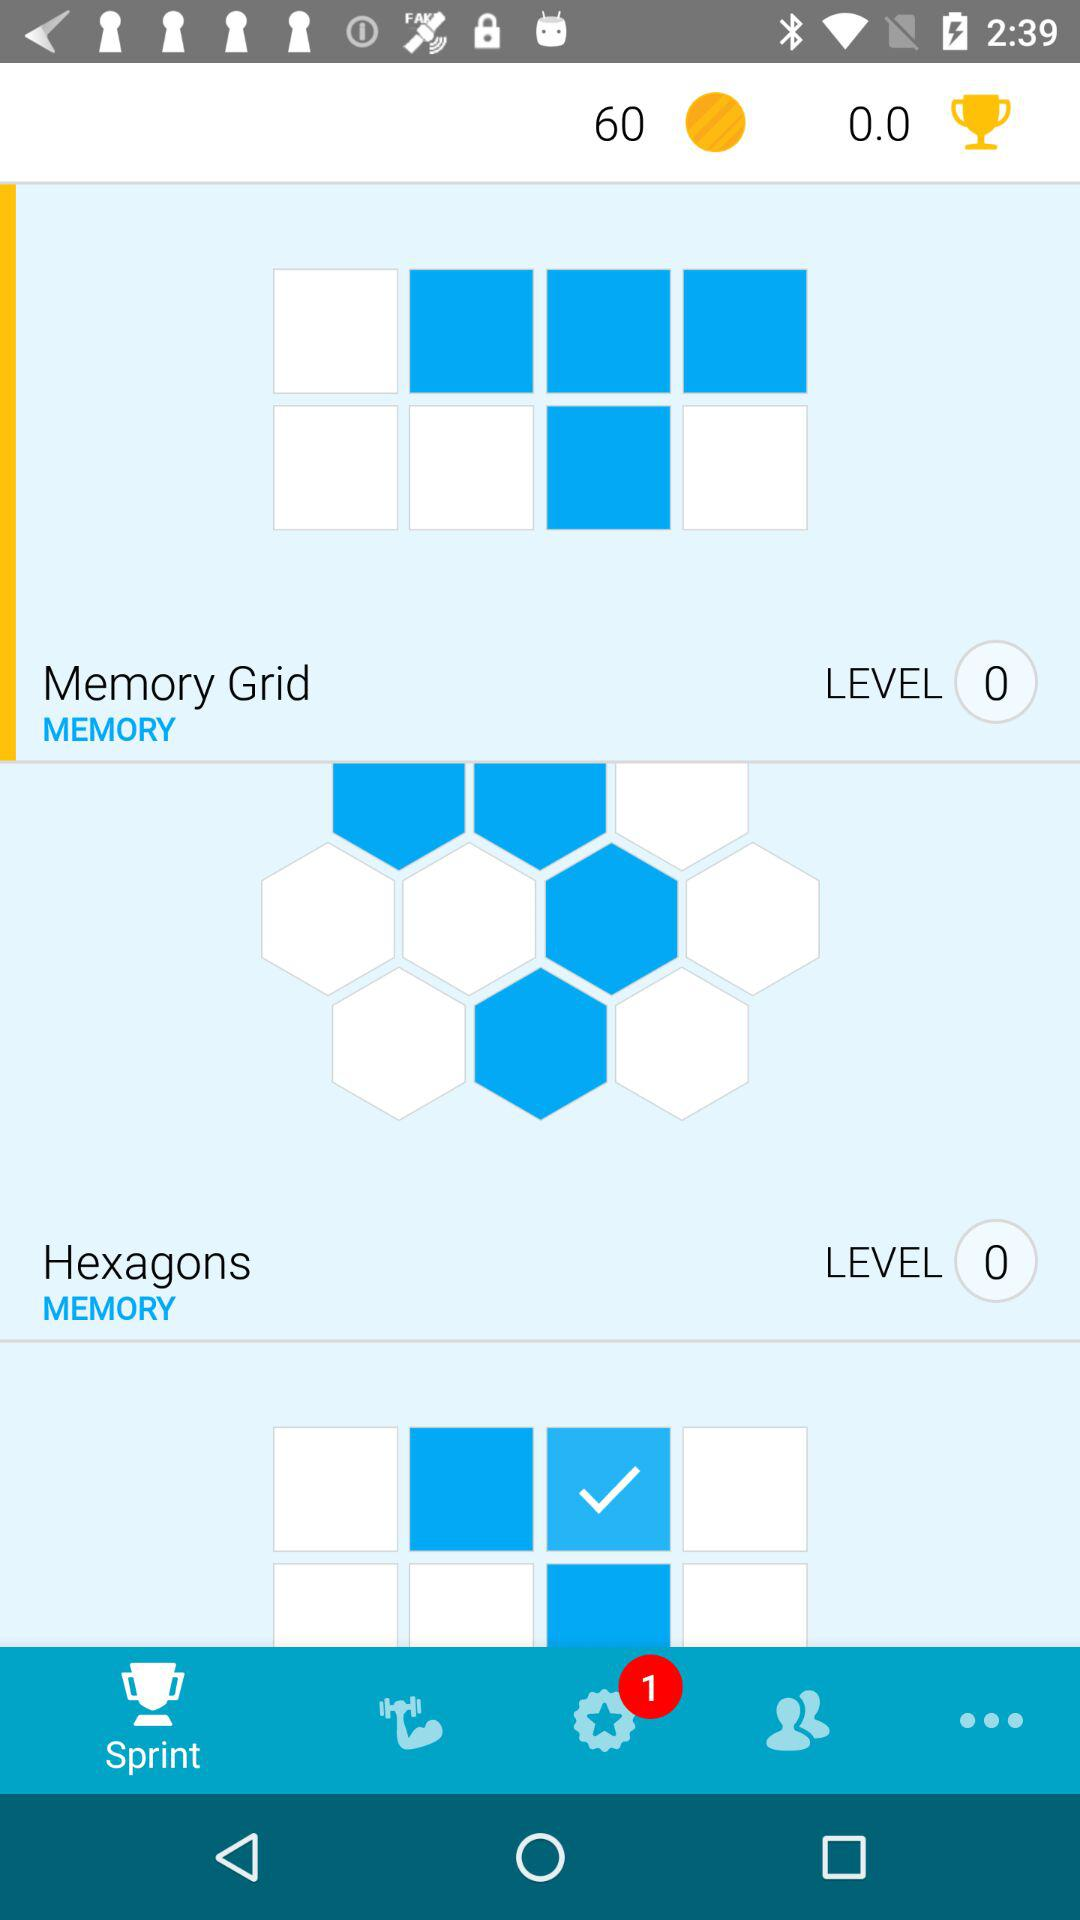How many new notifications are there? There is 1 new notification. 